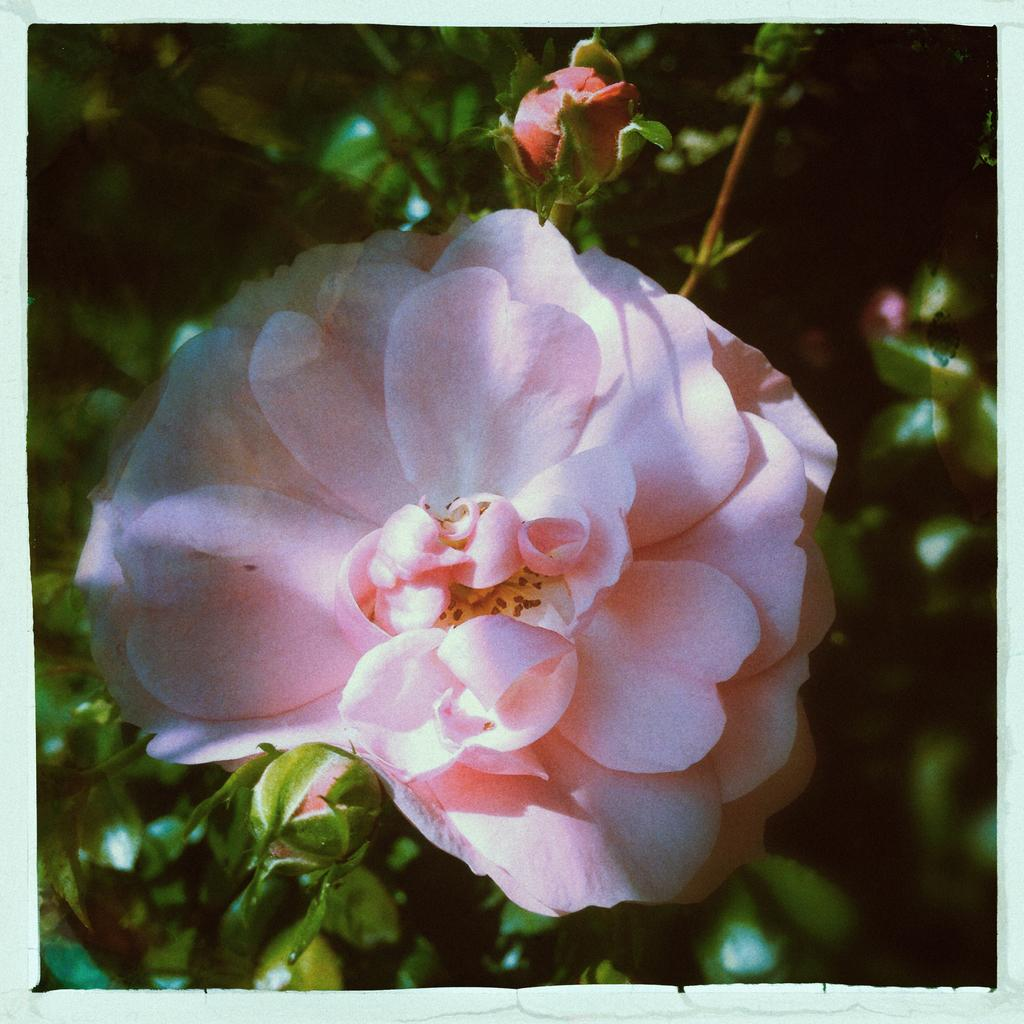What type of plant is featured in the image? There is a flower in the image. Can you describe the stage of growth of the plant? There are buds on the plant in the image. What can be observed around the edges of the image? The image has borders. What is the rate of the porter carrying the luggage in the image? There is no porter or luggage present in the image; it features a flower with buds and has borders. 